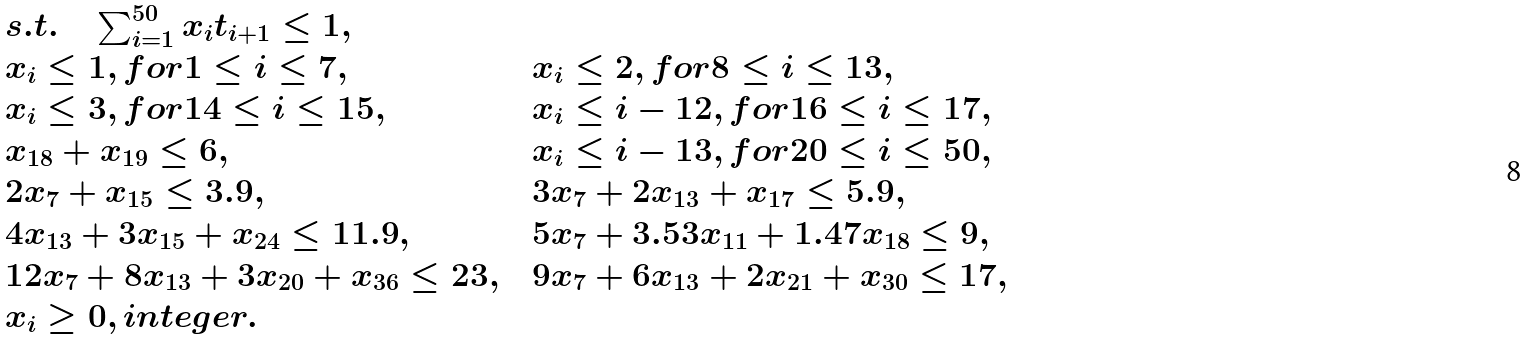Convert formula to latex. <formula><loc_0><loc_0><loc_500><loc_500>\begin{array} { l l l } s . t . \quad \sum _ { i = 1 } ^ { 5 0 } x _ { i } t _ { i + 1 } \leq 1 , & & \\ x _ { i } \leq 1 , f o r 1 \leq i \leq 7 , & & x _ { i } \leq 2 , f o r 8 \leq i \leq 1 3 , \\ x _ { i } \leq 3 , f o r 1 4 \leq i \leq 1 5 , & & x _ { i } \leq i - 1 2 , f o r 1 6 \leq i \leq 1 7 , \\ x _ { 1 8 } + x _ { 1 9 } \leq 6 , & & x _ { i } \leq i - 1 3 , f o r 2 0 \leq i \leq 5 0 , \\ 2 x _ { 7 } + x _ { 1 5 } \leq 3 . 9 , & & 3 x _ { 7 } + 2 x _ { 1 3 } + x _ { 1 7 } \leq 5 . 9 , \\ 4 x _ { 1 3 } + 3 x _ { 1 5 } + x _ { 2 4 } \leq 1 1 . 9 , & & 5 x _ { 7 } + 3 . 5 3 x _ { 1 1 } + 1 . 4 7 x _ { 1 8 } \leq 9 , \\ 1 2 x _ { 7 } + 8 x _ { 1 3 } + 3 x _ { 2 0 } + x _ { 3 6 } \leq 2 3 , & & 9 x _ { 7 } + 6 x _ { 1 3 } + 2 x _ { 2 1 } + x _ { 3 0 } \leq 1 7 , \\ x _ { i } \geq 0 , i n t e g e r . & & \end{array}</formula> 